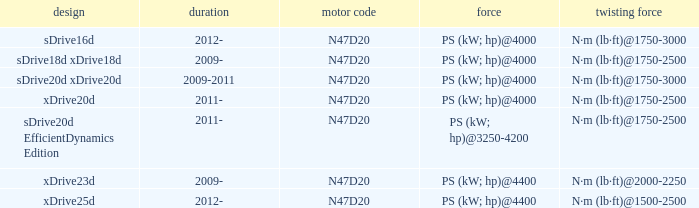What is the engine code of the xdrive23d model? N47D20. 